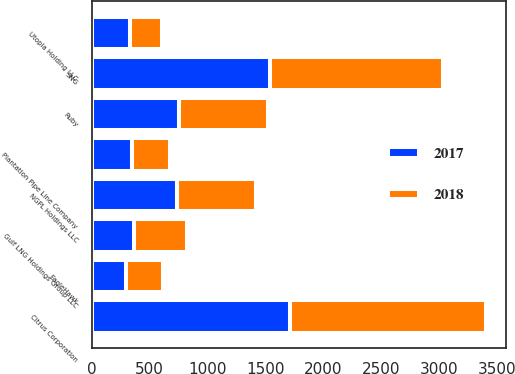Convert chart. <chart><loc_0><loc_0><loc_500><loc_500><stacked_bar_chart><ecel><fcel>Citrus Corporation<fcel>SNG<fcel>Ruby<fcel>NGPL Holdings LLC<fcel>Gulf LNG Holdings Group LLC<fcel>Plantation Pipe Line Company<fcel>Utopia Holding LLC<fcel>EagleHawk<nl><fcel>2017<fcel>1708<fcel>1536<fcel>750<fcel>733<fcel>361<fcel>344<fcel>333<fcel>299<nl><fcel>2018<fcel>1698<fcel>1495<fcel>774<fcel>687<fcel>461<fcel>331<fcel>276<fcel>314<nl></chart> 